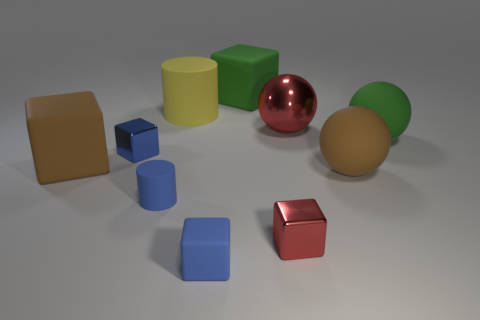There is a tiny block that is the same material as the yellow cylinder; what is its color?
Give a very brief answer. Blue. Is there another blue rubber cylinder of the same size as the blue cylinder?
Make the answer very short. No. There is a yellow thing that is the same size as the green rubber sphere; what is its shape?
Provide a succinct answer. Cylinder. Are there any blue objects that have the same shape as the large red object?
Ensure brevity in your answer.  No. Does the green cube have the same material as the blue block that is behind the brown block?
Provide a succinct answer. No. Is there a tiny block of the same color as the tiny cylinder?
Offer a very short reply. Yes. What number of other things are there of the same material as the red block
Your answer should be compact. 2. Does the metallic ball have the same color as the small metallic block that is on the right side of the small blue rubber cube?
Your response must be concise. Yes. Are there more large matte things to the left of the yellow matte object than purple matte things?
Your response must be concise. Yes. There is a tiny blue matte thing left of the cylinder behind the shiny sphere; how many red metal balls are in front of it?
Give a very brief answer. 0. 